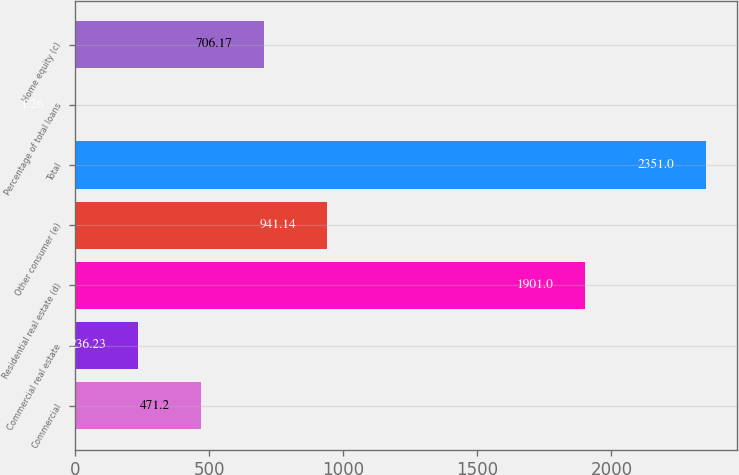Convert chart. <chart><loc_0><loc_0><loc_500><loc_500><bar_chart><fcel>Commercial<fcel>Commercial real estate<fcel>Residential real estate (d)<fcel>Other consumer (e)<fcel>Total<fcel>Percentage of total loans<fcel>Home equity (c)<nl><fcel>471.2<fcel>236.23<fcel>1901<fcel>941.14<fcel>2351<fcel>1.26<fcel>706.17<nl></chart> 